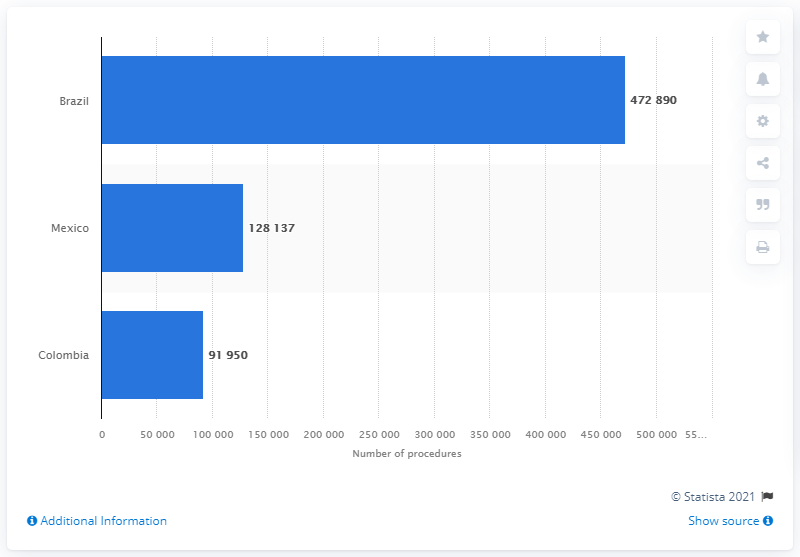Specify some key components in this picture. In 2017, a total of 472,890 breast procedures were performed in Brazil. 